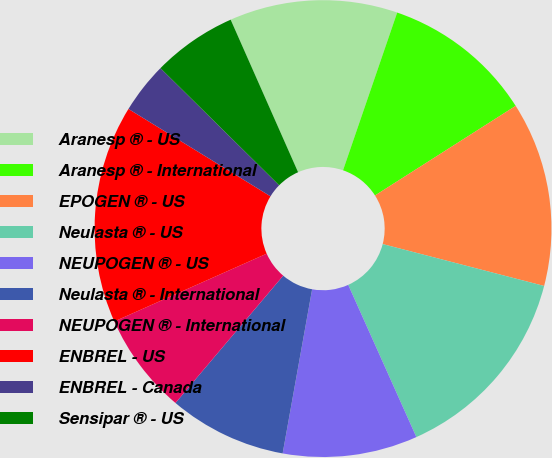Convert chart. <chart><loc_0><loc_0><loc_500><loc_500><pie_chart><fcel>Aranesp ® - US<fcel>Aranesp ® - International<fcel>EPOGEN ® - US<fcel>Neulasta ® - US<fcel>NEUPOGEN ® - US<fcel>Neulasta ® - International<fcel>NEUPOGEN ® - International<fcel>ENBREL - US<fcel>ENBREL - Canada<fcel>Sensipar ® - US<nl><fcel>11.89%<fcel>10.71%<fcel>13.07%<fcel>14.26%<fcel>9.53%<fcel>8.35%<fcel>7.16%<fcel>15.44%<fcel>3.62%<fcel>5.98%<nl></chart> 